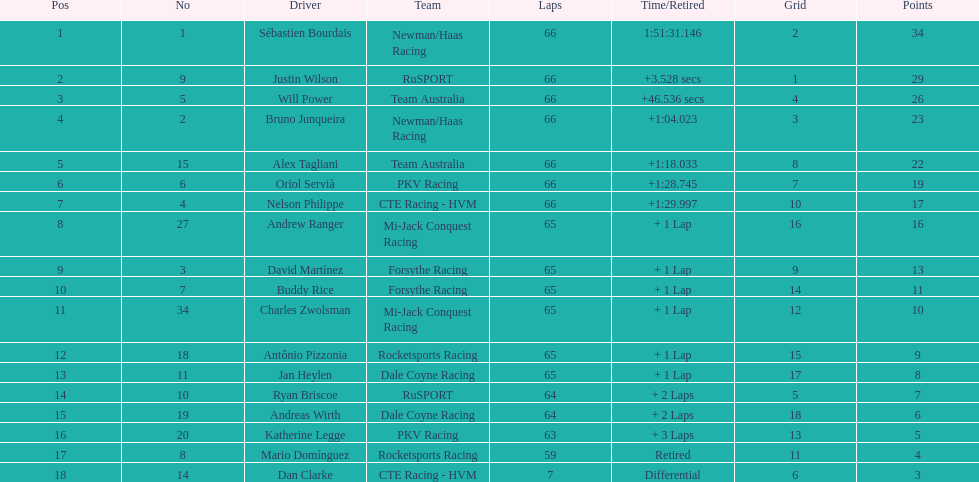Who finished directly after the driver who finished in 1:28.745? Nelson Philippe. 